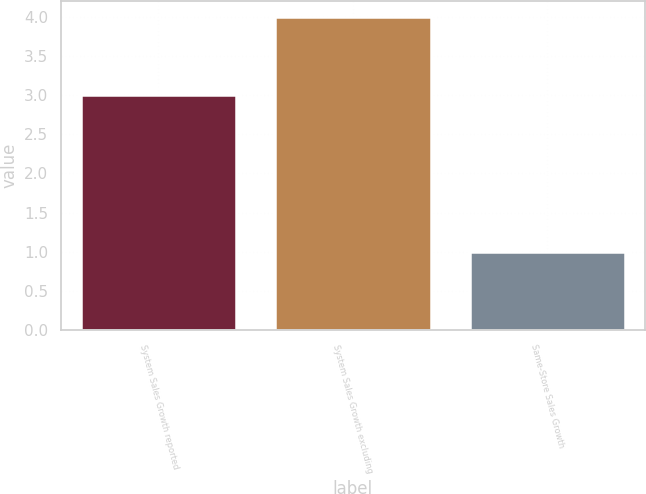<chart> <loc_0><loc_0><loc_500><loc_500><bar_chart><fcel>System Sales Growth reported<fcel>System Sales Growth excluding<fcel>Same-Store Sales Growth<nl><fcel>3<fcel>4<fcel>1<nl></chart> 